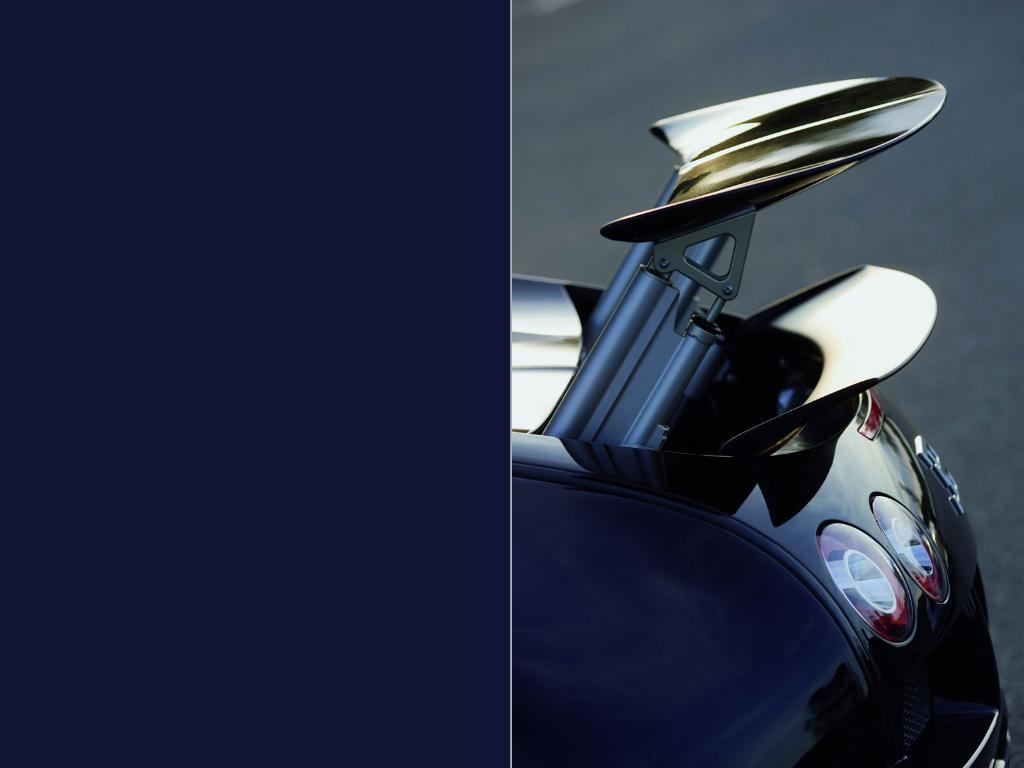What type of artwork is the image? The image is a collage. Where is an object located in the image? There is an object in the right corner of the image. What color can be found in the left corner of the image? There is blue color in the left corner of the image. Can you hear the letters crying in the image? There are no letters or crying sounds present in the image. 